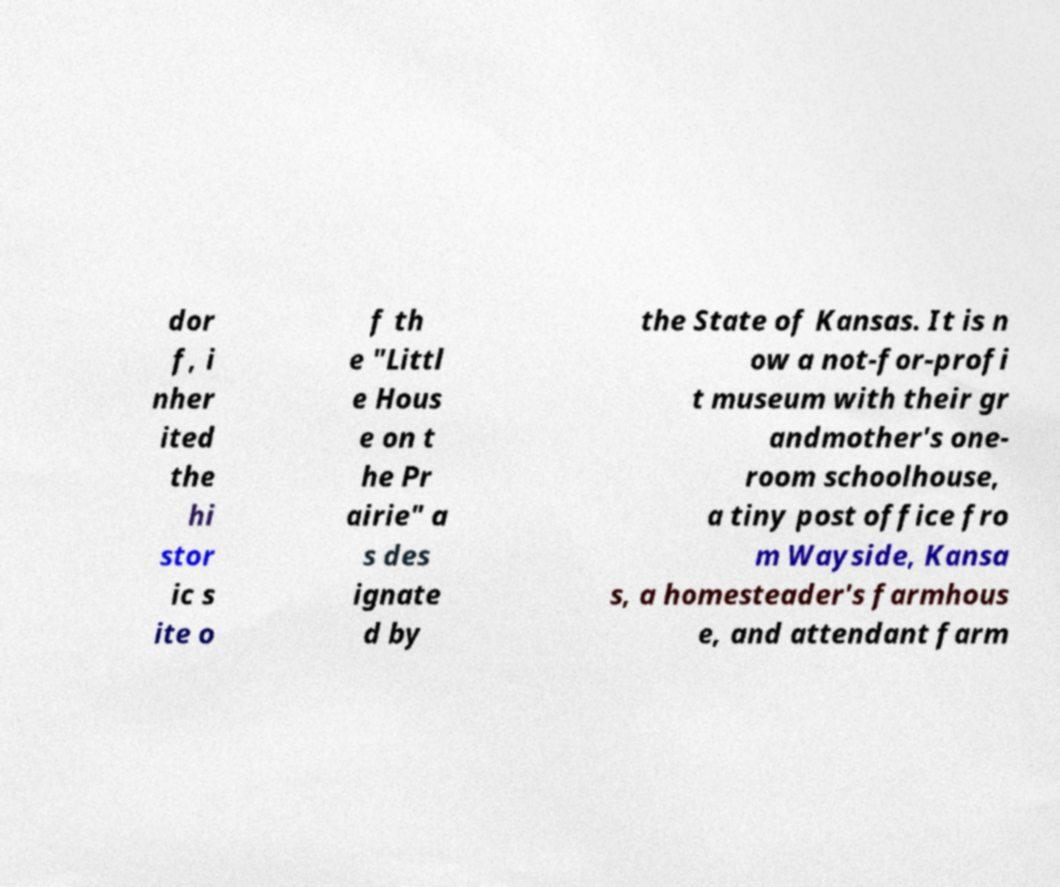Please read and relay the text visible in this image. What does it say? dor f, i nher ited the hi stor ic s ite o f th e "Littl e Hous e on t he Pr airie" a s des ignate d by the State of Kansas. It is n ow a not-for-profi t museum with their gr andmother's one- room schoolhouse, a tiny post office fro m Wayside, Kansa s, a homesteader's farmhous e, and attendant farm 